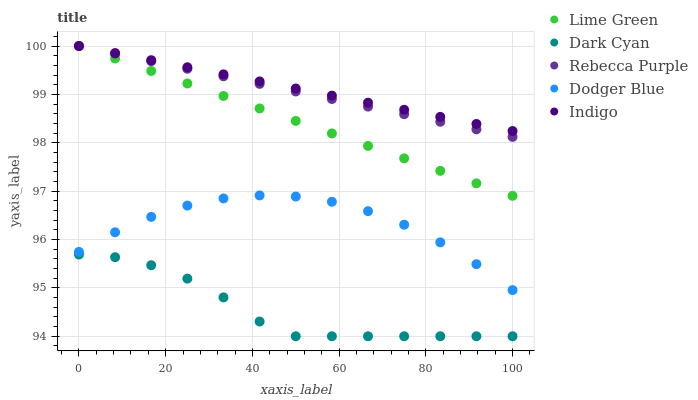Does Dark Cyan have the minimum area under the curve?
Answer yes or no. Yes. Does Indigo have the maximum area under the curve?
Answer yes or no. Yes. Does Dodger Blue have the minimum area under the curve?
Answer yes or no. No. Does Dodger Blue have the maximum area under the curve?
Answer yes or no. No. Is Rebecca Purple the smoothest?
Answer yes or no. Yes. Is Dark Cyan the roughest?
Answer yes or no. Yes. Is Dodger Blue the smoothest?
Answer yes or no. No. Is Dodger Blue the roughest?
Answer yes or no. No. Does Dark Cyan have the lowest value?
Answer yes or no. Yes. Does Dodger Blue have the lowest value?
Answer yes or no. No. Does Indigo have the highest value?
Answer yes or no. Yes. Does Dodger Blue have the highest value?
Answer yes or no. No. Is Dark Cyan less than Indigo?
Answer yes or no. Yes. Is Dodger Blue greater than Dark Cyan?
Answer yes or no. Yes. Does Indigo intersect Rebecca Purple?
Answer yes or no. Yes. Is Indigo less than Rebecca Purple?
Answer yes or no. No. Is Indigo greater than Rebecca Purple?
Answer yes or no. No. Does Dark Cyan intersect Indigo?
Answer yes or no. No. 